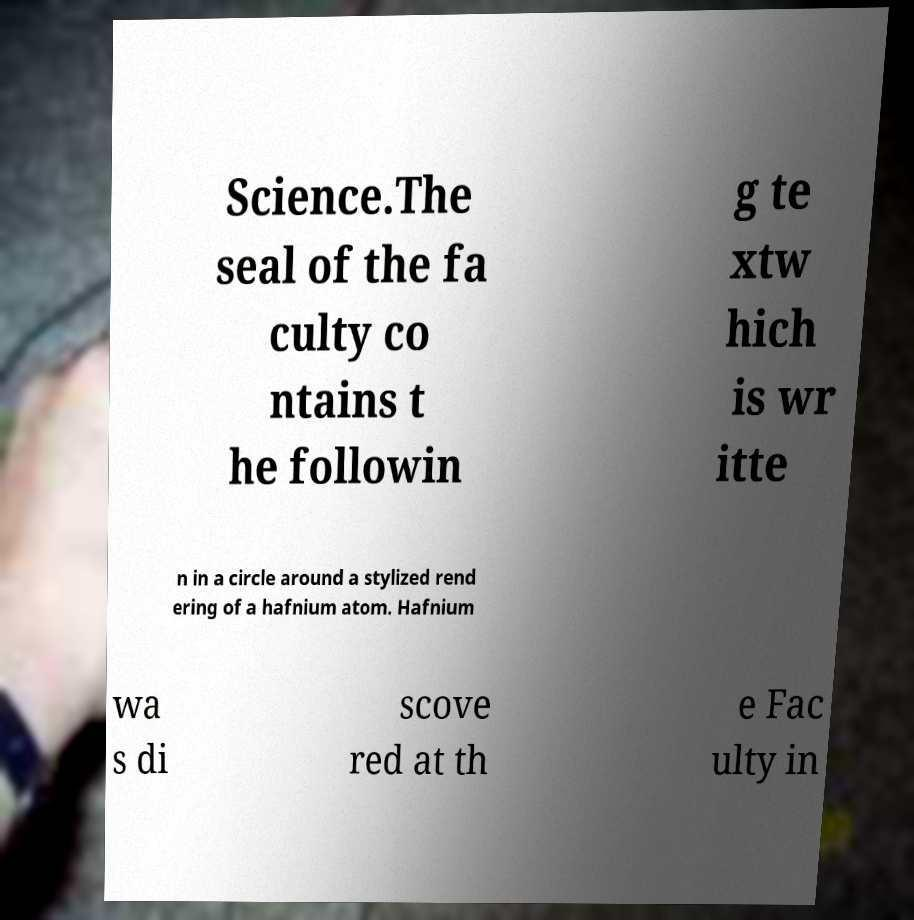I need the written content from this picture converted into text. Can you do that? Science.The seal of the fa culty co ntains t he followin g te xtw hich is wr itte n in a circle around a stylized rend ering of a hafnium atom. Hafnium wa s di scove red at th e Fac ulty in 